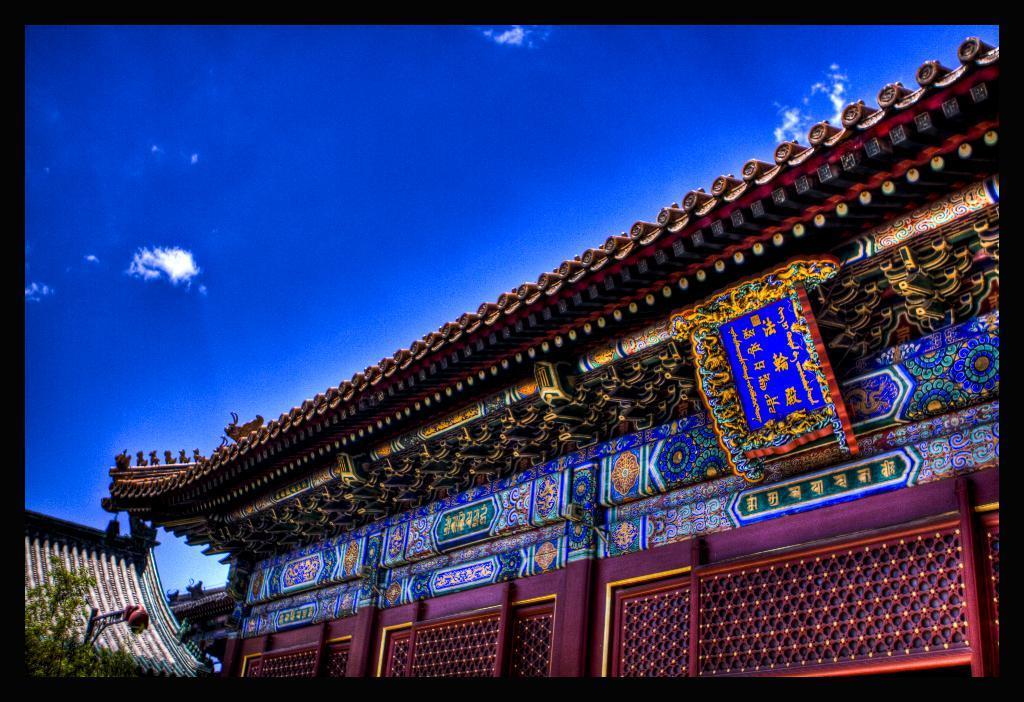How would you summarize this image in a sentence or two? In this image there are buildings, trees and sky. 